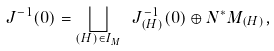<formula> <loc_0><loc_0><loc_500><loc_500>\ J ^ { - 1 } ( 0 ) = \bigsqcup _ { ( H ) \in I _ { M } } \ J ^ { - 1 } _ { ( H ) } ( 0 ) \oplus N ^ { \ast } M _ { ( H ) } ,</formula> 